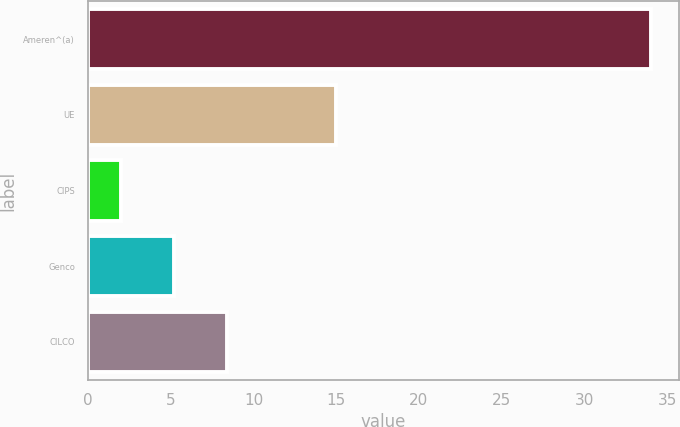<chart> <loc_0><loc_0><loc_500><loc_500><bar_chart><fcel>Ameren^(a)<fcel>UE<fcel>CIPS<fcel>Genco<fcel>CILCO<nl><fcel>34<fcel>15<fcel>2<fcel>5.2<fcel>8.4<nl></chart> 